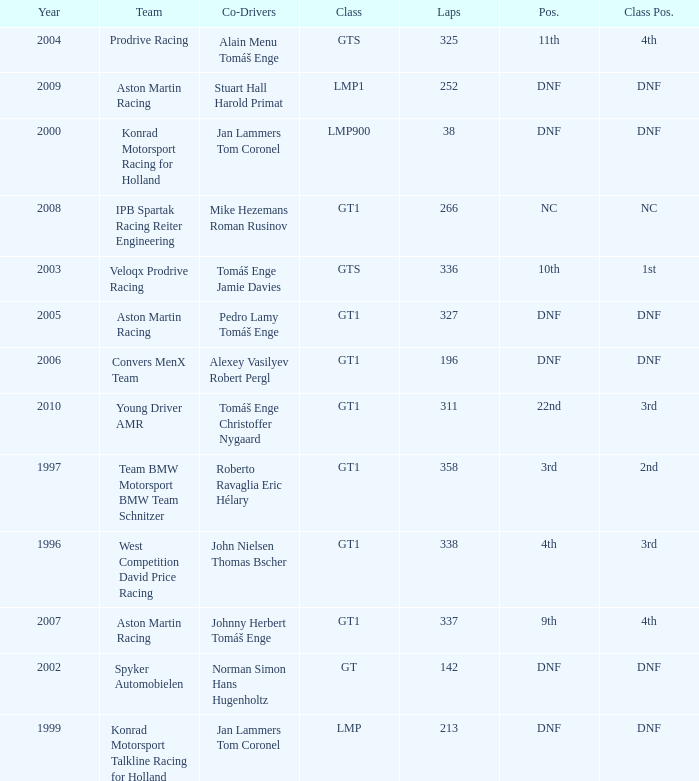Which team finished 3rd in class with 337 laps before 2008? West Competition David Price Racing. Parse the table in full. {'header': ['Year', 'Team', 'Co-Drivers', 'Class', 'Laps', 'Pos.', 'Class Pos.'], 'rows': [['2004', 'Prodrive Racing', 'Alain Menu Tomáš Enge', 'GTS', '325', '11th', '4th'], ['2009', 'Aston Martin Racing', 'Stuart Hall Harold Primat', 'LMP1', '252', 'DNF', 'DNF'], ['2000', 'Konrad Motorsport Racing for Holland', 'Jan Lammers Tom Coronel', 'LMP900', '38', 'DNF', 'DNF'], ['2008', 'IPB Spartak Racing Reiter Engineering', 'Mike Hezemans Roman Rusinov', 'GT1', '266', 'NC', 'NC'], ['2003', 'Veloqx Prodrive Racing', 'Tomáš Enge Jamie Davies', 'GTS', '336', '10th', '1st'], ['2005', 'Aston Martin Racing', 'Pedro Lamy Tomáš Enge', 'GT1', '327', 'DNF', 'DNF'], ['2006', 'Convers MenX Team', 'Alexey Vasilyev Robert Pergl', 'GT1', '196', 'DNF', 'DNF'], ['2010', 'Young Driver AMR', 'Tomáš Enge Christoffer Nygaard', 'GT1', '311', '22nd', '3rd'], ['1997', 'Team BMW Motorsport BMW Team Schnitzer', 'Roberto Ravaglia Eric Hélary', 'GT1', '358', '3rd', '2nd'], ['1996', 'West Competition David Price Racing', 'John Nielsen Thomas Bscher', 'GT1', '338', '4th', '3rd'], ['2007', 'Aston Martin Racing', 'Johnny Herbert Tomáš Enge', 'GT1', '337', '9th', '4th'], ['2002', 'Spyker Automobielen', 'Norman Simon Hans Hugenholtz', 'GT', '142', 'DNF', 'DNF'], ['1999', 'Konrad Motorsport Talkline Racing for Holland', 'Jan Lammers Tom Coronel', 'LMP', '213', 'DNF', 'DNF']]} 